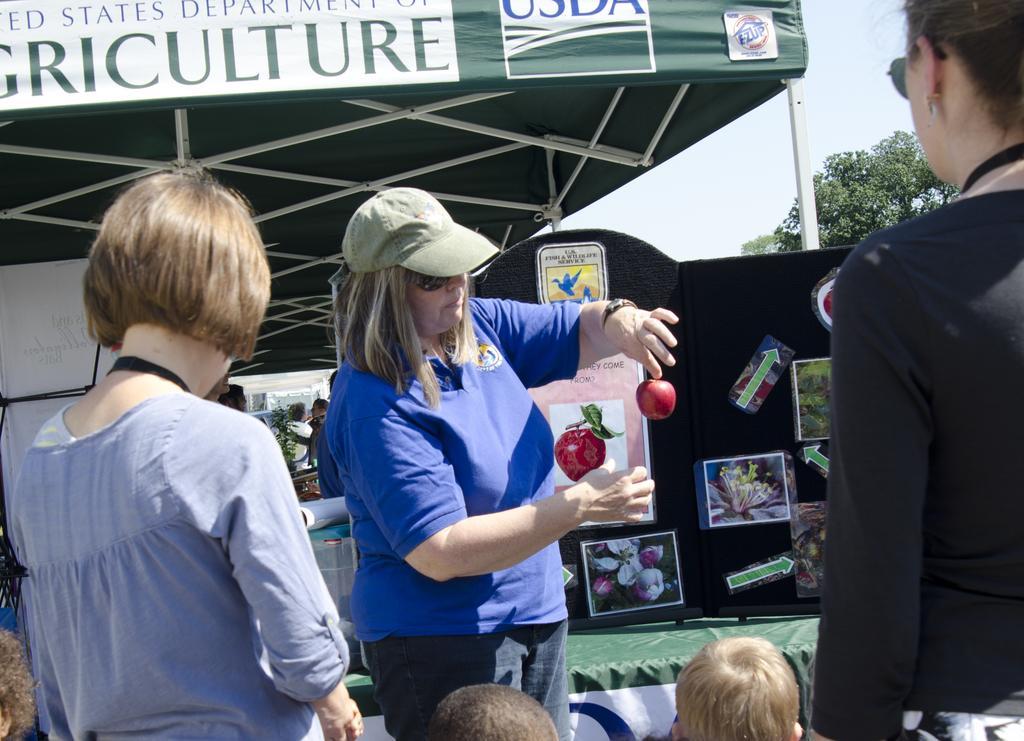Describe this image in one or two sentences. In this picture we can see a group of people, one woman is wearing a cap, holding an apple, here we can see a tent, noticeboard, posters, trees and some objects and we can see sky in the background. 